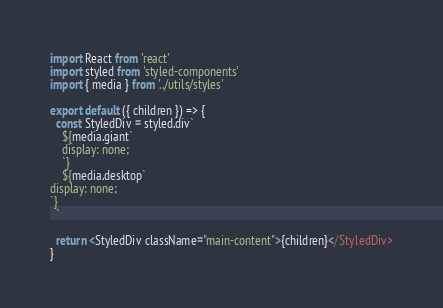<code> <loc_0><loc_0><loc_500><loc_500><_JavaScript_>import React from 'react'
import styled from 'styled-components'
import { media } from '../utils/styles'

export default ({ children }) => {
  const StyledDiv = styled.div`
    ${media.giant`
    display: none;
    `}
    ${media.desktop`
display: none;
`}
  `

  return <StyledDiv className="main-content">{children}</StyledDiv>
}
</code> 